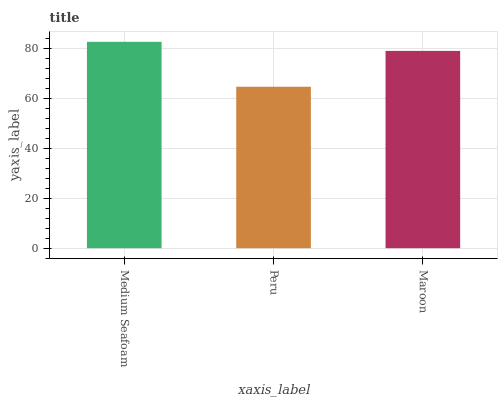Is Maroon the minimum?
Answer yes or no. No. Is Maroon the maximum?
Answer yes or no. No. Is Maroon greater than Peru?
Answer yes or no. Yes. Is Peru less than Maroon?
Answer yes or no. Yes. Is Peru greater than Maroon?
Answer yes or no. No. Is Maroon less than Peru?
Answer yes or no. No. Is Maroon the high median?
Answer yes or no. Yes. Is Maroon the low median?
Answer yes or no. Yes. Is Peru the high median?
Answer yes or no. No. Is Medium Seafoam the low median?
Answer yes or no. No. 